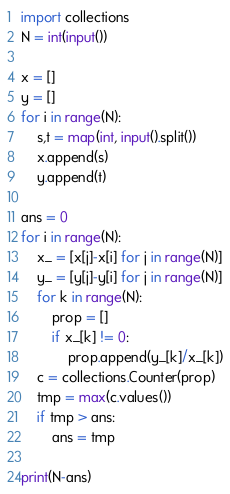Convert code to text. <code><loc_0><loc_0><loc_500><loc_500><_Python_>
import collections
N = int(input())

x = []
y = []
for i in range(N):
    s,t = map(int, input().split())
    x.append(s)
    y.append(t)

ans = 0
for i in range(N):
    x_ = [x[j]-x[i] for j in range(N)]
    y_ = [y[j]-y[i] for j in range(N)]
    for k in range(N):
        prop = []
        if x_[k] != 0:
            prop.append(y_[k]/x_[k])
    c = collections.Counter(prop)
    tmp = max(c.values())
    if tmp > ans:
        ans = tmp

print(N-ans)</code> 